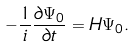<formula> <loc_0><loc_0><loc_500><loc_500>- \frac { 1 } { i } \frac { \partial \Psi _ { 0 } } { \partial t } = H \Psi _ { 0 } .</formula> 